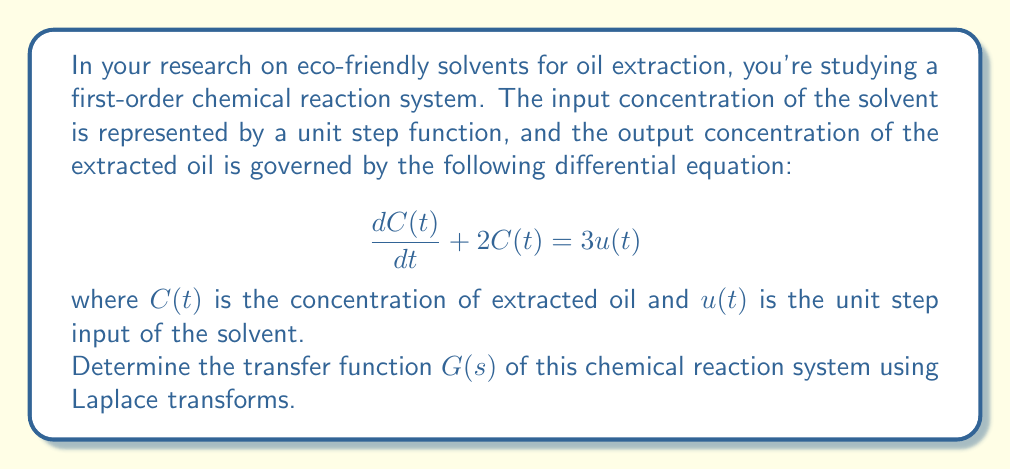Teach me how to tackle this problem. To solve this problem, we'll follow these steps:

1) First, let's take the Laplace transform of both sides of the differential equation:

   $$\mathcal{L}\left\{\frac{dC(t)}{dt} + 2C(t)\right\} = \mathcal{L}\{3u(t)\}$$

2) Using the properties of Laplace transforms:
   - $\mathcal{L}\{\frac{dC(t)}{dt}\} = sC(s) - C(0)$, where $C(0)$ is the initial condition
   - $\mathcal{L}\{2C(t)\} = 2C(s)$
   - $\mathcal{L}\{3u(t)\} = \frac{3}{s}$

   Assuming $C(0) = 0$ (initial concentration of extracted oil is zero), we get:

   $$sC(s) + 2C(s) = \frac{3}{s}$$

3) Factoring out $C(s)$:

   $$(s + 2)C(s) = \frac{3}{s}$$

4) Solving for $C(s)$:

   $$C(s) = \frac{3}{s(s + 2)}$$

5) The transfer function $G(s)$ is defined as the ratio of the output $C(s)$ to the input $U(s)$ in the s-domain. Here, $U(s) = \frac{1}{s}$ (Laplace transform of the unit step function).

   $$G(s) = \frac{C(s)}{U(s)} = \frac{3}{s(s + 2)} \cdot \frac{s}{1} = \frac{3}{s + 2}$$

Thus, the transfer function of the chemical reaction system is $G(s) = \frac{3}{s + 2}$.
Answer: $$G(s) = \frac{3}{s + 2}$$ 